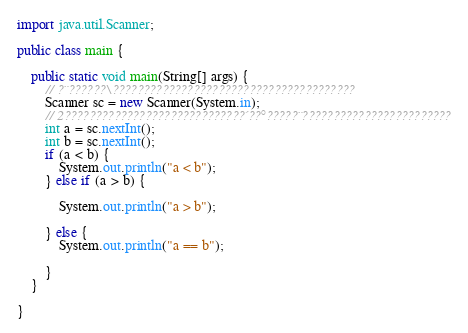<code> <loc_0><loc_0><loc_500><loc_500><_Java_>import java.util.Scanner;

public class main {

	public static void main(String[] args) {
		// ?¨??????\???????????????????????????????????????
		Scanner sc = new Scanner(System.in);
		// 2?????????????????????????????´??°?????¨????????????????????????
		int a = sc.nextInt();
		int b = sc.nextInt();
		if (a < b) {
			System.out.println("a < b");
		} else if (a > b) {

			System.out.println("a > b");

		} else {
			System.out.println("a == b");

		}
	}

}</code> 